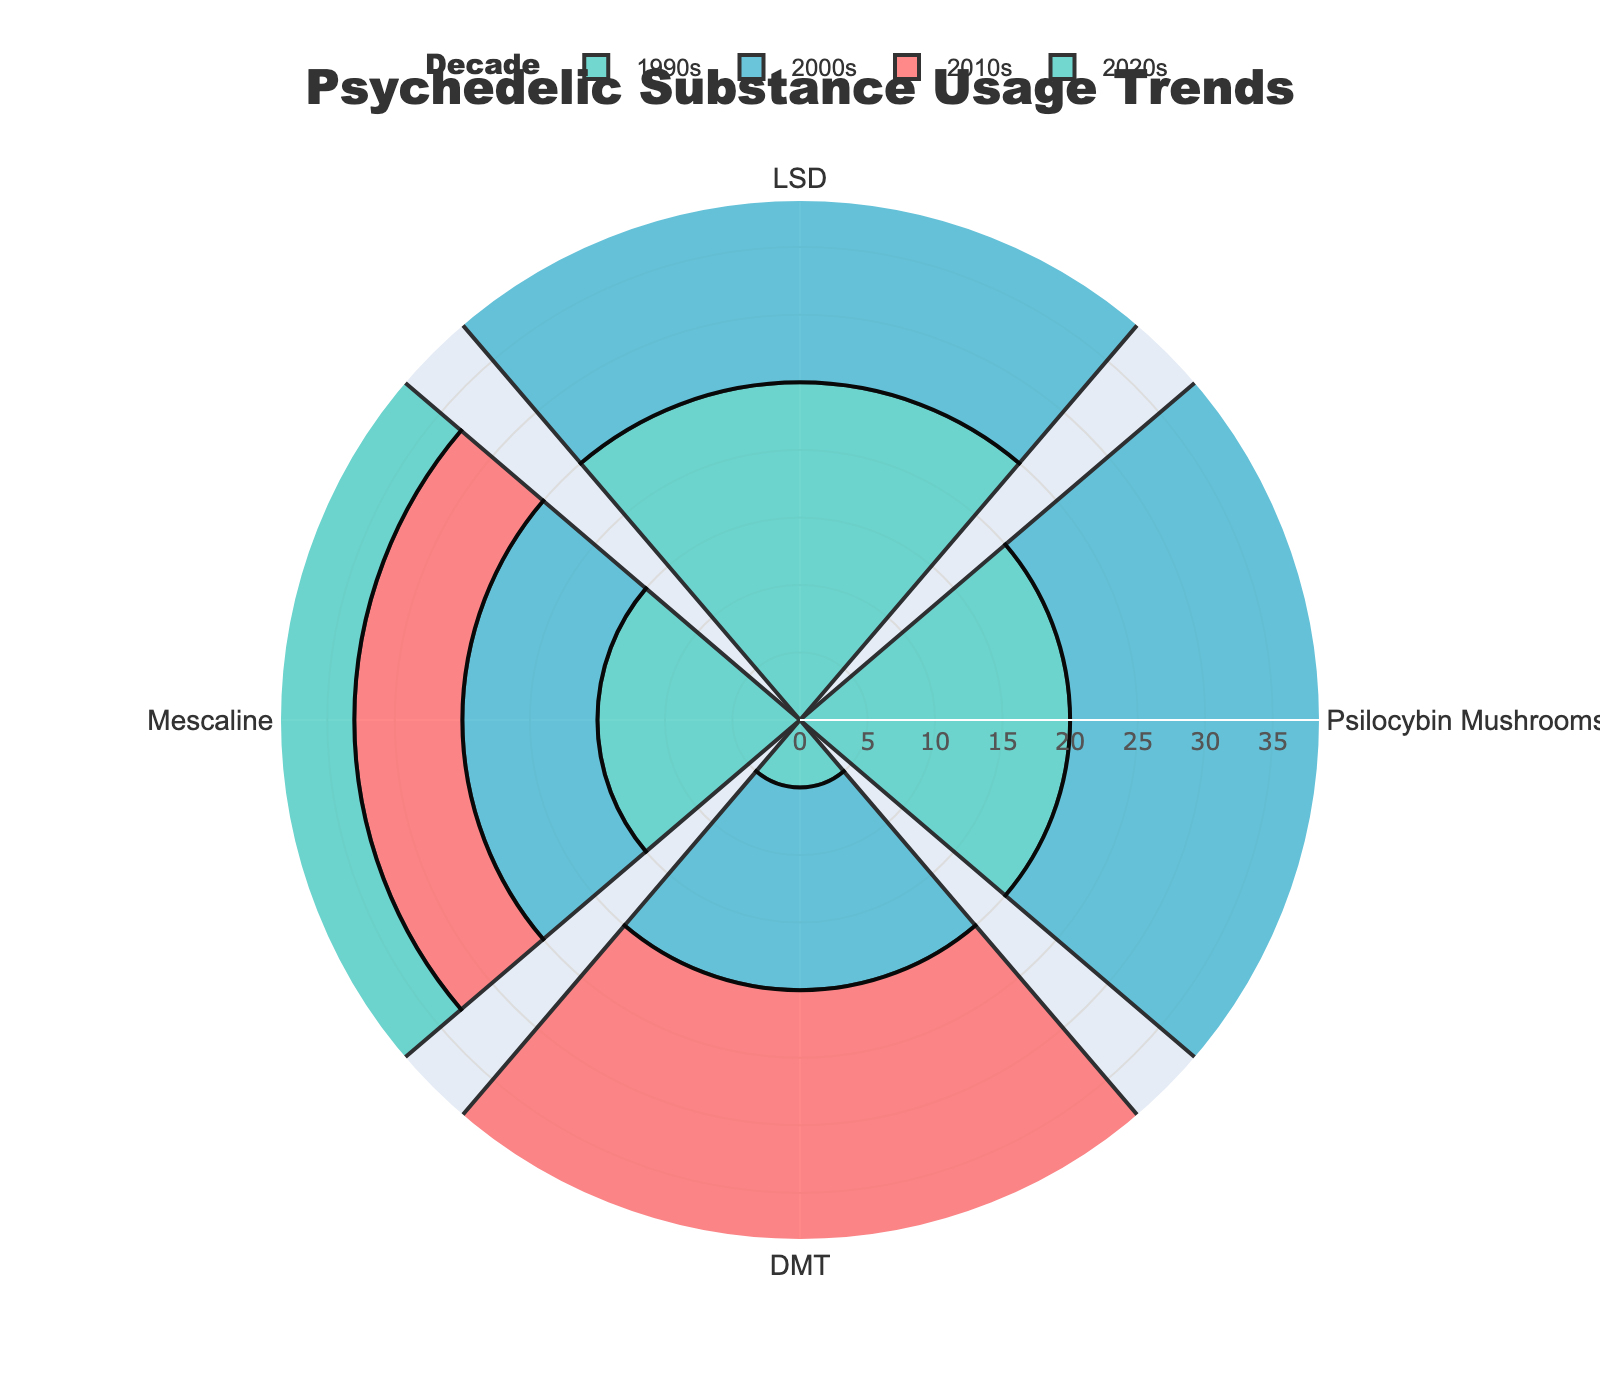What is the title of the figure? The title is displayed prominently at the top of the figure.
Answer: Psychedelic Substance Usage Trends Which decade had the highest usage of LSD? By looking at the values for LSD over the decades, the 2020s had the highest usage with a value of 30.
Answer: 2020s How does Psilocybin Mushrooms usage in the 2010s compare to the 1990s? The value for Psilocybin Mushrooms in the 2010s is 27 and in the 1990s it is 20. The usage increased by 7 units over these decades.
Answer: Increased by 7 Which psychedelic substance had the lowest usage in the 2000s? By comparing the values, DMT had the lowest usage in the 2000s with a value of 15.
Answer: Mescaline What is the average usage of Mescaline across all decades? The values for Mescaline are 15, 10, 8, and 12 for the 1990s, 2000s, 2010s, and 2020s respectively. The average usage is calculated as (15 + 10 + 8 + 12) / 4 = 11.25.
Answer: 11.25 Which substance showed the most significant increase in usage from the 1990s to the 2020s? By calculating the difference over the decades, LSD increased by 5, Psilocybin Mushrooms increased by 15, DMT increased by 20, and Mescaline decreased by 3. DMT showed the most significant increase from 5 to 25.
Answer: DMT In which decade did the total usage of all substances reach its peak? Summing the values for each decade, the totals are 65, 68, 77, and 102 for the 1990s, 2000s, 2010s, and 2020s respectively. The peak is in the 2020s with a total of 102.
Answer: 2020s How does DMT usage in the 2020s compare to Psilocybin Mushrooms usage in the 1990s? DMT usage in the 2020s is 25 while Psilocybin Mushrooms usage in the 1990s is 20. DMT usage is 5 units higher.
Answer: 5 units higher Which substance had a constant or decreasing trend over the decades? By observing the trends, Mescaline usage decreased from the 1990s to the 2020s, having values of 15, 10, 8, and 12.
Answer: Mescaline 